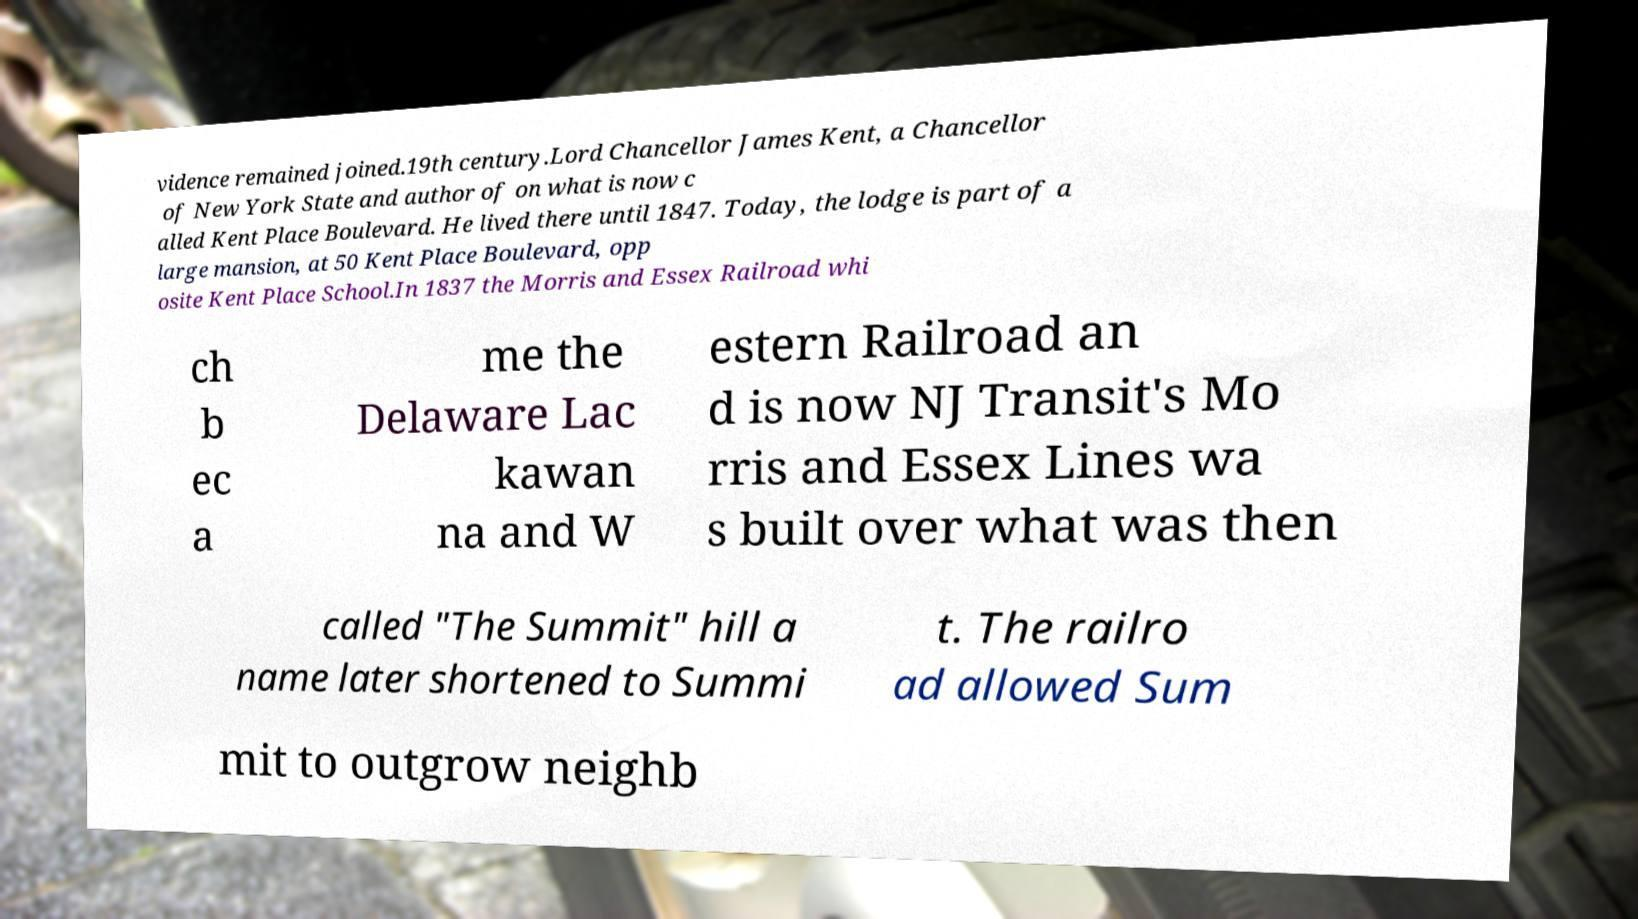Can you accurately transcribe the text from the provided image for me? vidence remained joined.19th century.Lord Chancellor James Kent, a Chancellor of New York State and author of on what is now c alled Kent Place Boulevard. He lived there until 1847. Today, the lodge is part of a large mansion, at 50 Kent Place Boulevard, opp osite Kent Place School.In 1837 the Morris and Essex Railroad whi ch b ec a me the Delaware Lac kawan na and W estern Railroad an d is now NJ Transit's Mo rris and Essex Lines wa s built over what was then called "The Summit" hill a name later shortened to Summi t. The railro ad allowed Sum mit to outgrow neighb 